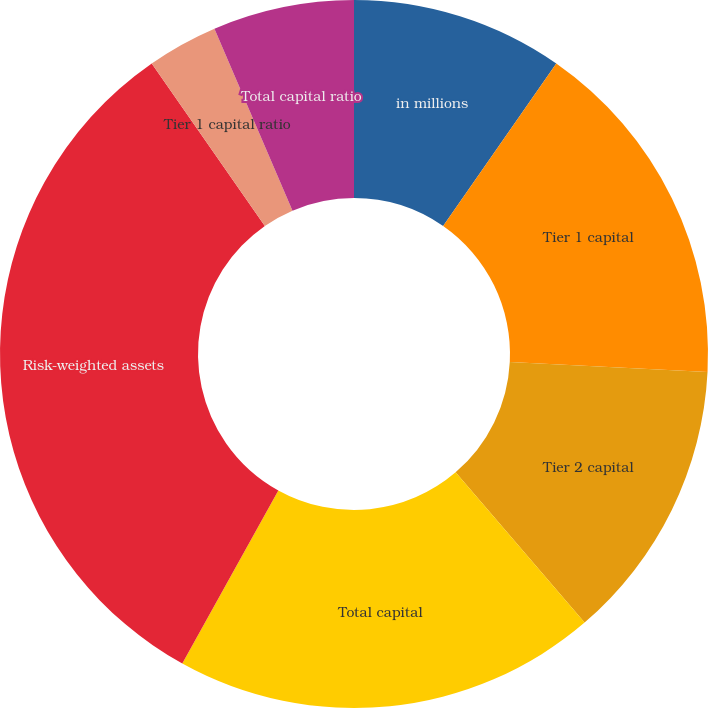<chart> <loc_0><loc_0><loc_500><loc_500><pie_chart><fcel>in millions<fcel>Tier 1 capital<fcel>Tier 2 capital<fcel>Total capital<fcel>Risk-weighted assets<fcel>Tier 1 capital ratio<fcel>Total capital ratio<fcel>Tier 1 leverage ratio<nl><fcel>9.68%<fcel>16.13%<fcel>12.9%<fcel>19.35%<fcel>32.26%<fcel>3.23%<fcel>6.45%<fcel>0.0%<nl></chart> 